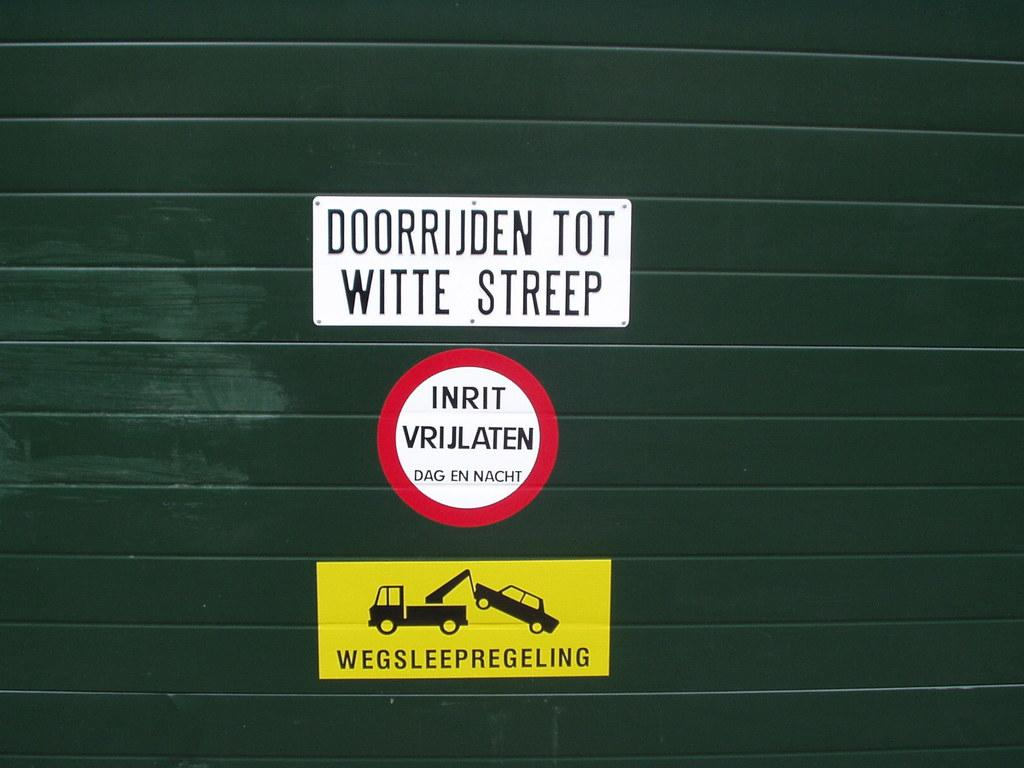What is on the wall in the image? There are stickers on the wall in the image. What time of day is it in the image, and is the goose present? The time of day is not mentioned in the image, and there is no goose present. 